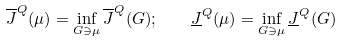<formula> <loc_0><loc_0><loc_500><loc_500>\overline { J } ^ { Q } ( \mu ) = \inf _ { G \ni \mu } \overline { J } ^ { Q } ( G ) ; \quad \underline { J } ^ { Q } ( \mu ) = \inf _ { G \ni \mu } \underline { J } ^ { Q } ( G )</formula> 